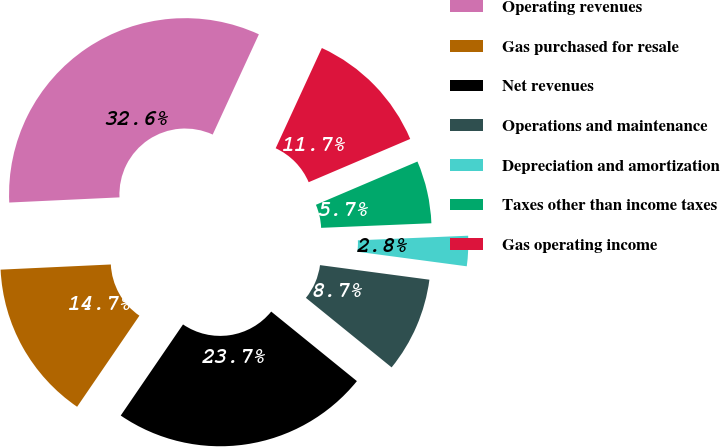Convert chart to OTSL. <chart><loc_0><loc_0><loc_500><loc_500><pie_chart><fcel>Operating revenues<fcel>Gas purchased for resale<fcel>Net revenues<fcel>Operations and maintenance<fcel>Depreciation and amortization<fcel>Taxes other than income taxes<fcel>Gas operating income<nl><fcel>32.62%<fcel>14.71%<fcel>23.7%<fcel>8.74%<fcel>2.77%<fcel>5.75%<fcel>11.72%<nl></chart> 